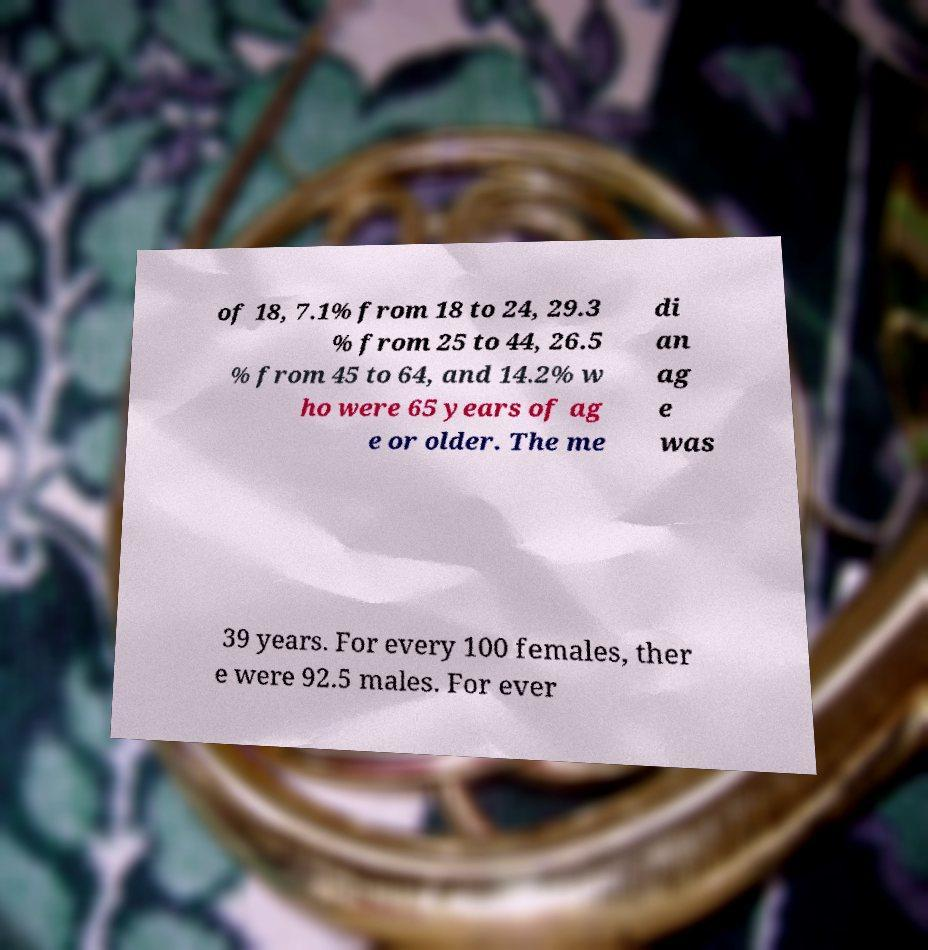There's text embedded in this image that I need extracted. Can you transcribe it verbatim? of 18, 7.1% from 18 to 24, 29.3 % from 25 to 44, 26.5 % from 45 to 64, and 14.2% w ho were 65 years of ag e or older. The me di an ag e was 39 years. For every 100 females, ther e were 92.5 males. For ever 